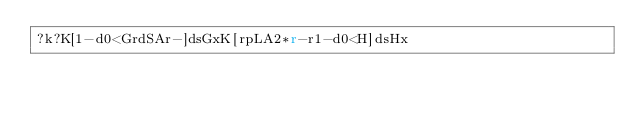Convert code to text. <code><loc_0><loc_0><loc_500><loc_500><_dc_>?k?K[1-d0<GrdSAr-]dsGxK[rpLA2*r-r1-d0<H]dsHx</code> 